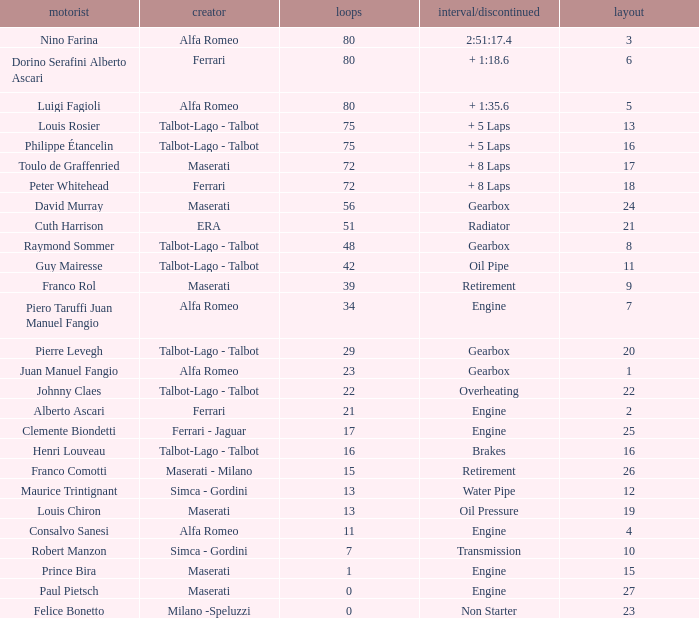When the driver is Juan Manuel Fangio and laps is less than 39, what is the highest grid? 1.0. 